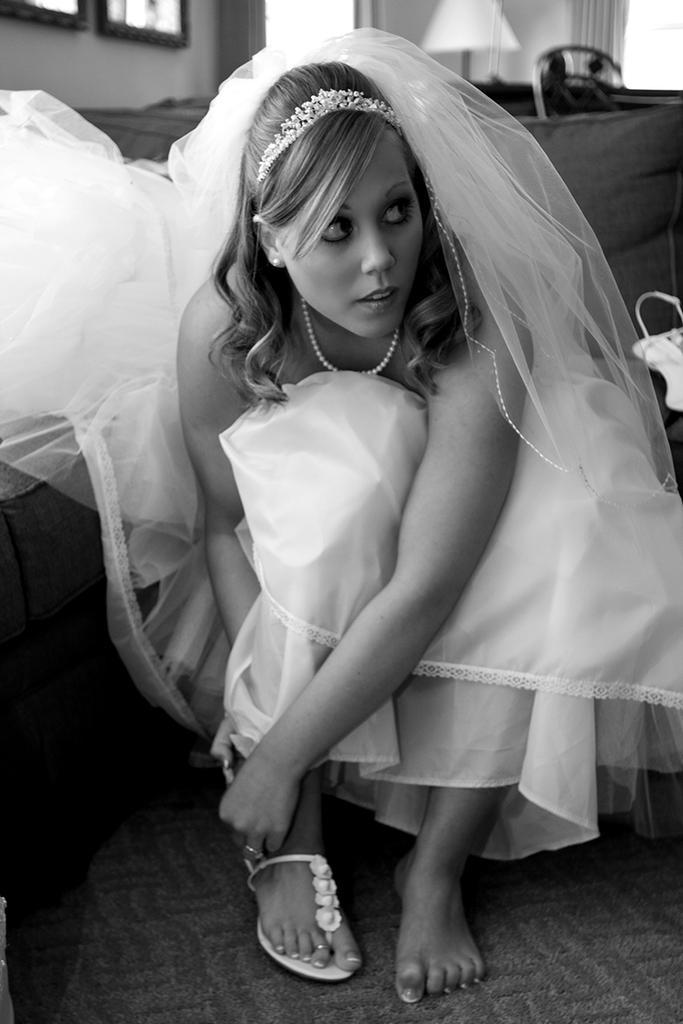Could you give a brief overview of what you see in this image? In this image I can see a woman in squat position on the floor. In the background I can see a bed, lamp, photo frames on a wall and a curtain. This image is taken may be in a room. 